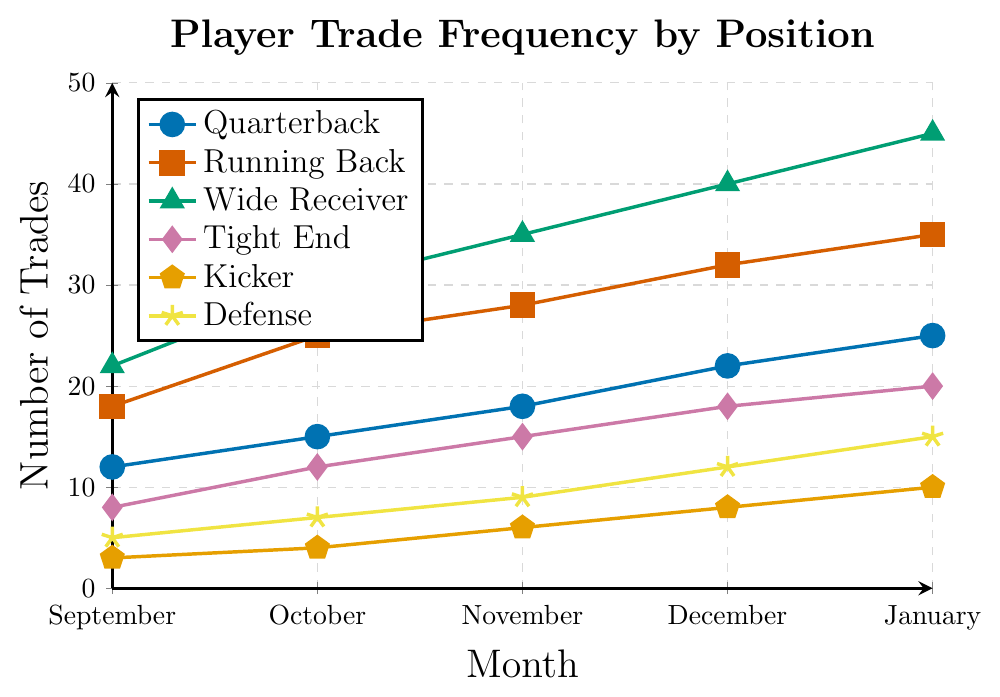Which position has the highest trade frequency in January? By observing the figure, the Wide Receiver position reaches the peak in January with 45 trades.
Answer: Wide Receiver How many trades were there for Tight Ends in November compared to Kicker trades in the same month? The figure shows 15 trades for Tight Ends in November, while Kickers had 6 trades.
Answer: 15 for Tight Ends, 6 for Kickers Which month showed the sharpest increase in trades for Running Backs? From September (18 trades) to October (25 trades), the increase is 7 trades. Compare this to other monthly increases: 3 (October-November), 4 (November-December), and 3 (December-January). So, the largest increase occurred from September to October.
Answer: Between September and October What is the total number of trades for Defense across all months? Sum the trades for Defense: 5 (September) + 7 (October) + 9 (November) + 12 (December) + 15 (January) = 48.
Answer: 48 Which month had the lowest total number of trades for all positions combined? Sum the trades for each month:
  - September: 12 + 18 + 22 + 8 + 3 + 5 = 68
  - October: 15 + 25 + 30 + 12 + 4 + 7 = 93
  - November: 18 + 28 + 35 + 15 + 6 + 9 = 111
  - December: 22 + 32 + 40 + 18 + 8 + 12 = 132
  - January: 25 + 35 + 45 + 20 + 10 + 15 = 150
So, September has the lowest total.
Answer: September By how much did the trade frequency for Quarterbacks increase from September to January? The number of trades for Quarterbacks increased from 12 in September to 25 in January. The increase is 25 - 12 = 13 trades.
Answer: 13 Which two positions have the closest trade frequencies in December? In December, Tight End had 18 trades and Defense had 12 trades. Compare these with others: Quarterback (22), Running Back (32), Wide Receiver (40), Kicker (8). The closest pair is Tight End and Defense: 18 and 12 respectively.
Answer: Tight End and Defense What is the average number of trades for Wide Receivers per month? The trades for Wide Receivers each month are 22 (September), 30 (October), 35 (November), 40 (December), and 45 (January). The average is (22+30+35+40+45)/5 = 34.4.
Answer: 34.4 